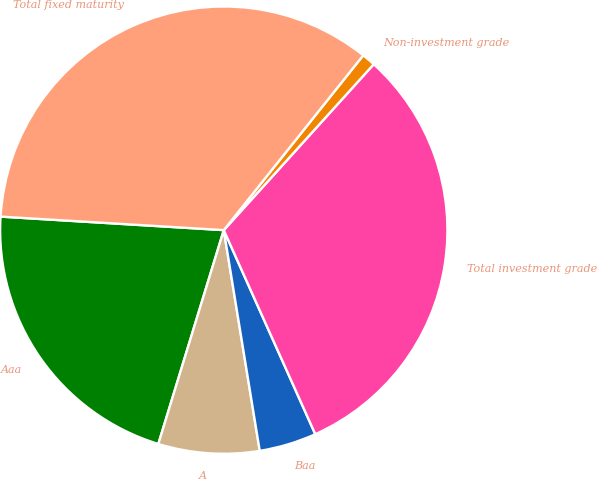Convert chart. <chart><loc_0><loc_0><loc_500><loc_500><pie_chart><fcel>Aaa<fcel>A<fcel>Baa<fcel>Total investment grade<fcel>Non-investment grade<fcel>Total fixed maturity<nl><fcel>21.24%<fcel>7.3%<fcel>4.14%<fcel>31.6%<fcel>0.98%<fcel>34.76%<nl></chart> 